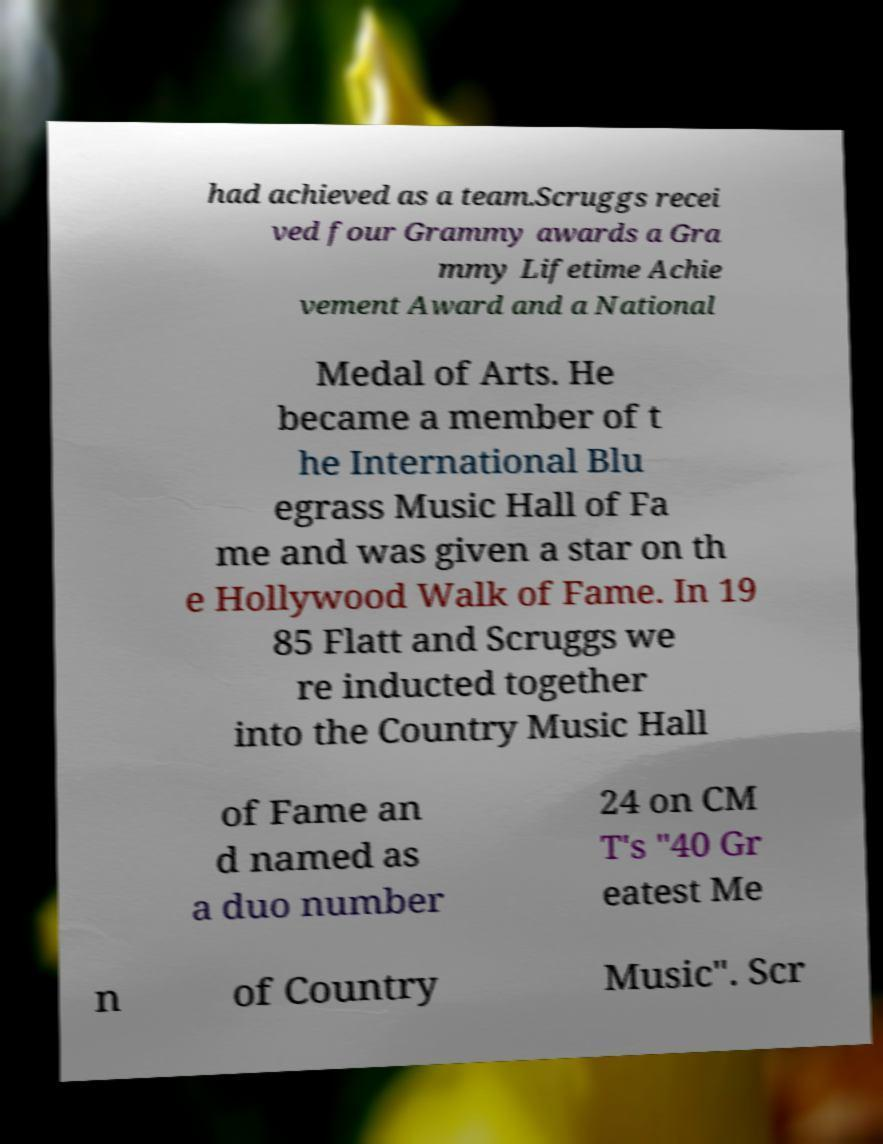I need the written content from this picture converted into text. Can you do that? had achieved as a team.Scruggs recei ved four Grammy awards a Gra mmy Lifetime Achie vement Award and a National Medal of Arts. He became a member of t he International Blu egrass Music Hall of Fa me and was given a star on th e Hollywood Walk of Fame. In 19 85 Flatt and Scruggs we re inducted together into the Country Music Hall of Fame an d named as a duo number 24 on CM T's "40 Gr eatest Me n of Country Music". Scr 